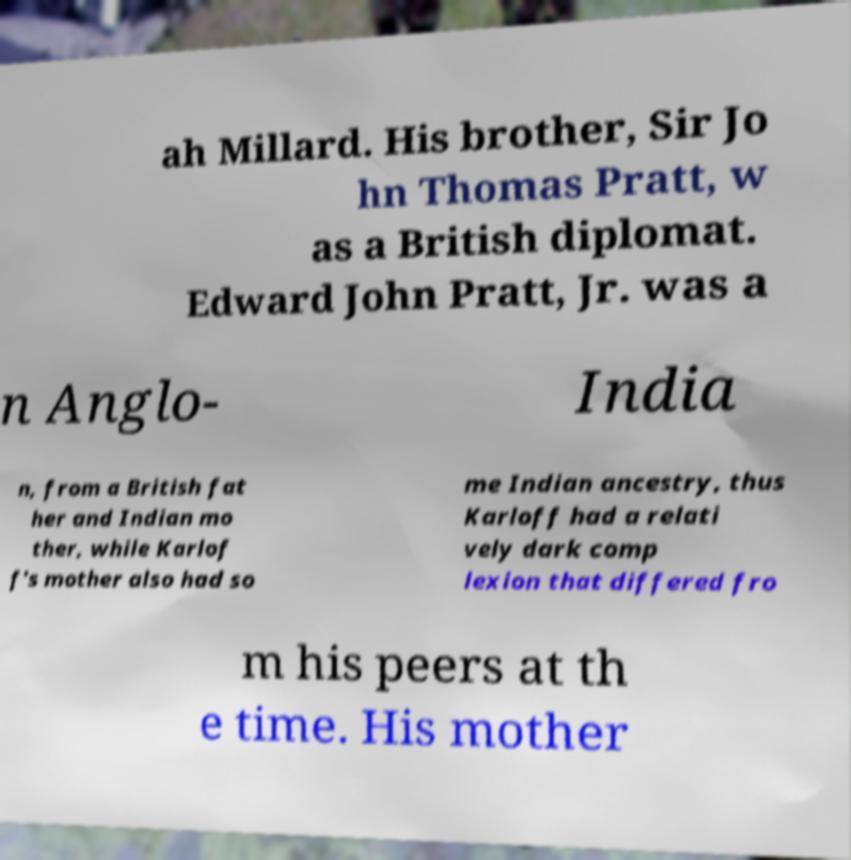What messages or text are displayed in this image? I need them in a readable, typed format. ah Millard. His brother, Sir Jo hn Thomas Pratt, w as a British diplomat. Edward John Pratt, Jr. was a n Anglo- India n, from a British fat her and Indian mo ther, while Karlof f's mother also had so me Indian ancestry, thus Karloff had a relati vely dark comp lexion that differed fro m his peers at th e time. His mother 